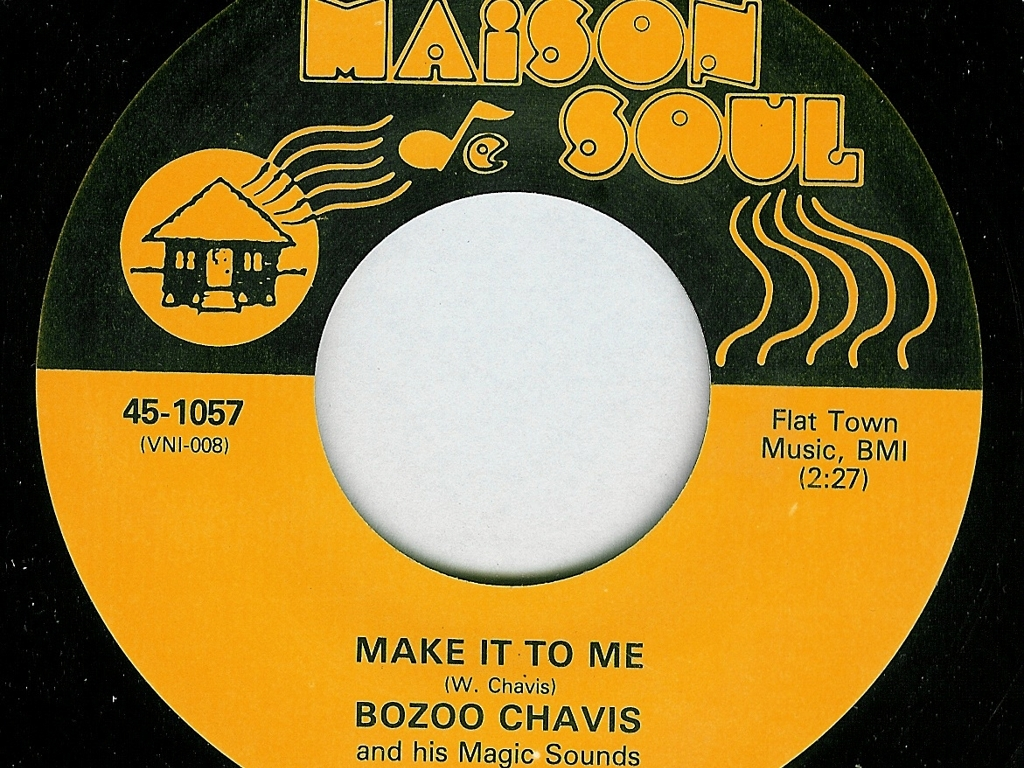Can you tell me more about the style of art used on this record label? Certainly! The art style on the label is simplistic and functional, typical of mid-20th-century record labels. It features bold text and minimalistic iconography to convey the record's artist and the soulful nature of the music genre it represents. The house with music notes emulates the 'Maison de Soul' or 'House of Soul' theme, which is reflective of the soul music era's emphasis on emotion and depth. 